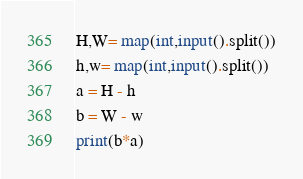Convert code to text. <code><loc_0><loc_0><loc_500><loc_500><_Python_>H,W= map(int,input().split())
h,w= map(int,input().split())
a = H - h
b = W - w
print(b*a)</code> 